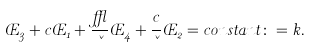Convert formula to latex. <formula><loc_0><loc_0><loc_500><loc_500>\phi _ { 3 } + c \phi _ { 1 } + \frac { \epsilon } { \kappa } \phi _ { 4 } + \frac { c } { \kappa } \phi _ { 2 } = c o n s t a n t \colon = k .</formula> 